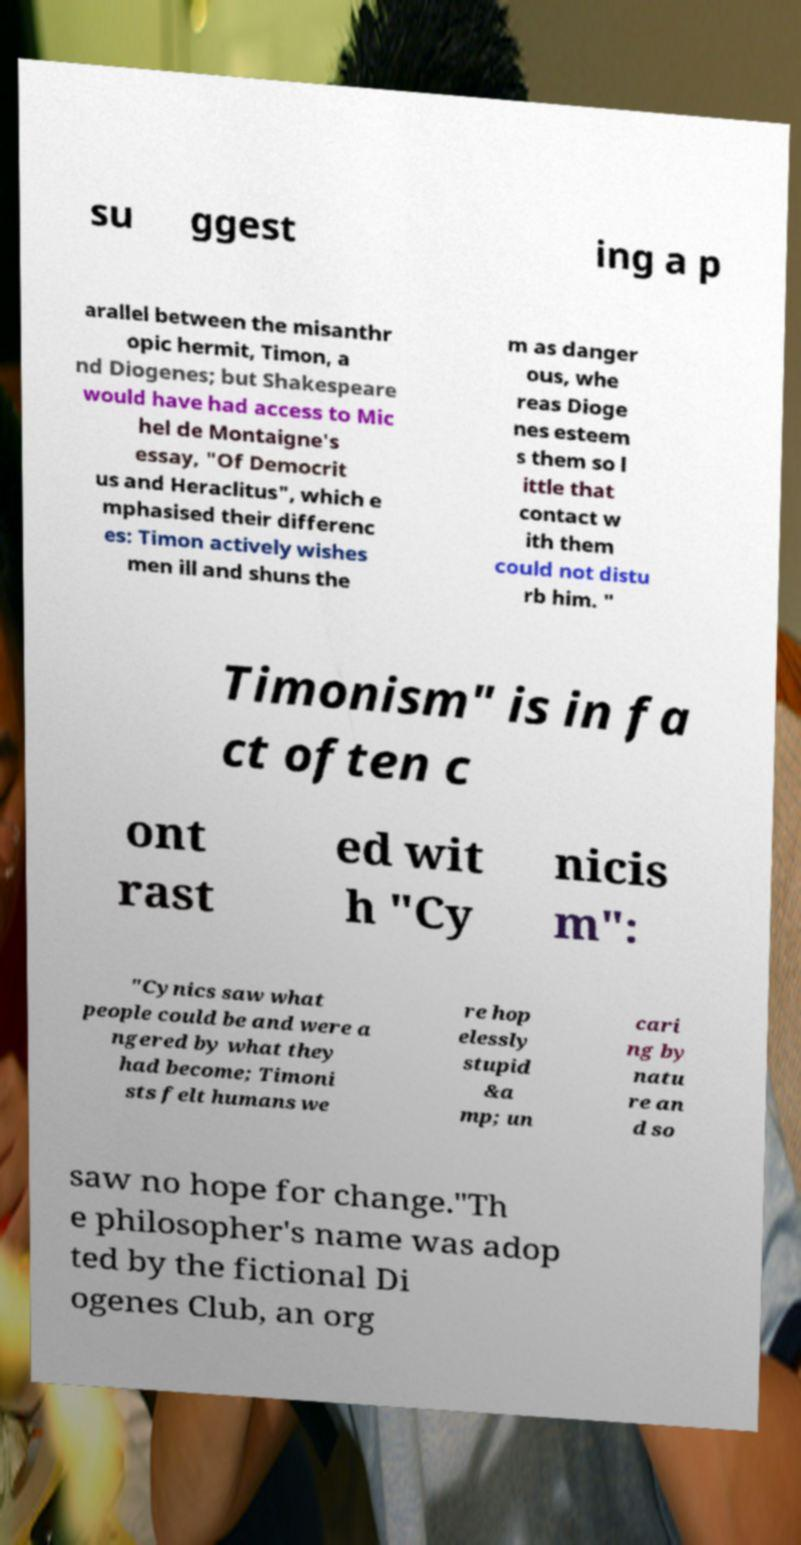Can you accurately transcribe the text from the provided image for me? su ggest ing a p arallel between the misanthr opic hermit, Timon, a nd Diogenes; but Shakespeare would have had access to Mic hel de Montaigne's essay, "Of Democrit us and Heraclitus", which e mphasised their differenc es: Timon actively wishes men ill and shuns the m as danger ous, whe reas Dioge nes esteem s them so l ittle that contact w ith them could not distu rb him. " Timonism" is in fa ct often c ont rast ed wit h "Cy nicis m": "Cynics saw what people could be and were a ngered by what they had become; Timoni sts felt humans we re hop elessly stupid &a mp; un cari ng by natu re an d so saw no hope for change."Th e philosopher's name was adop ted by the fictional Di ogenes Club, an org 